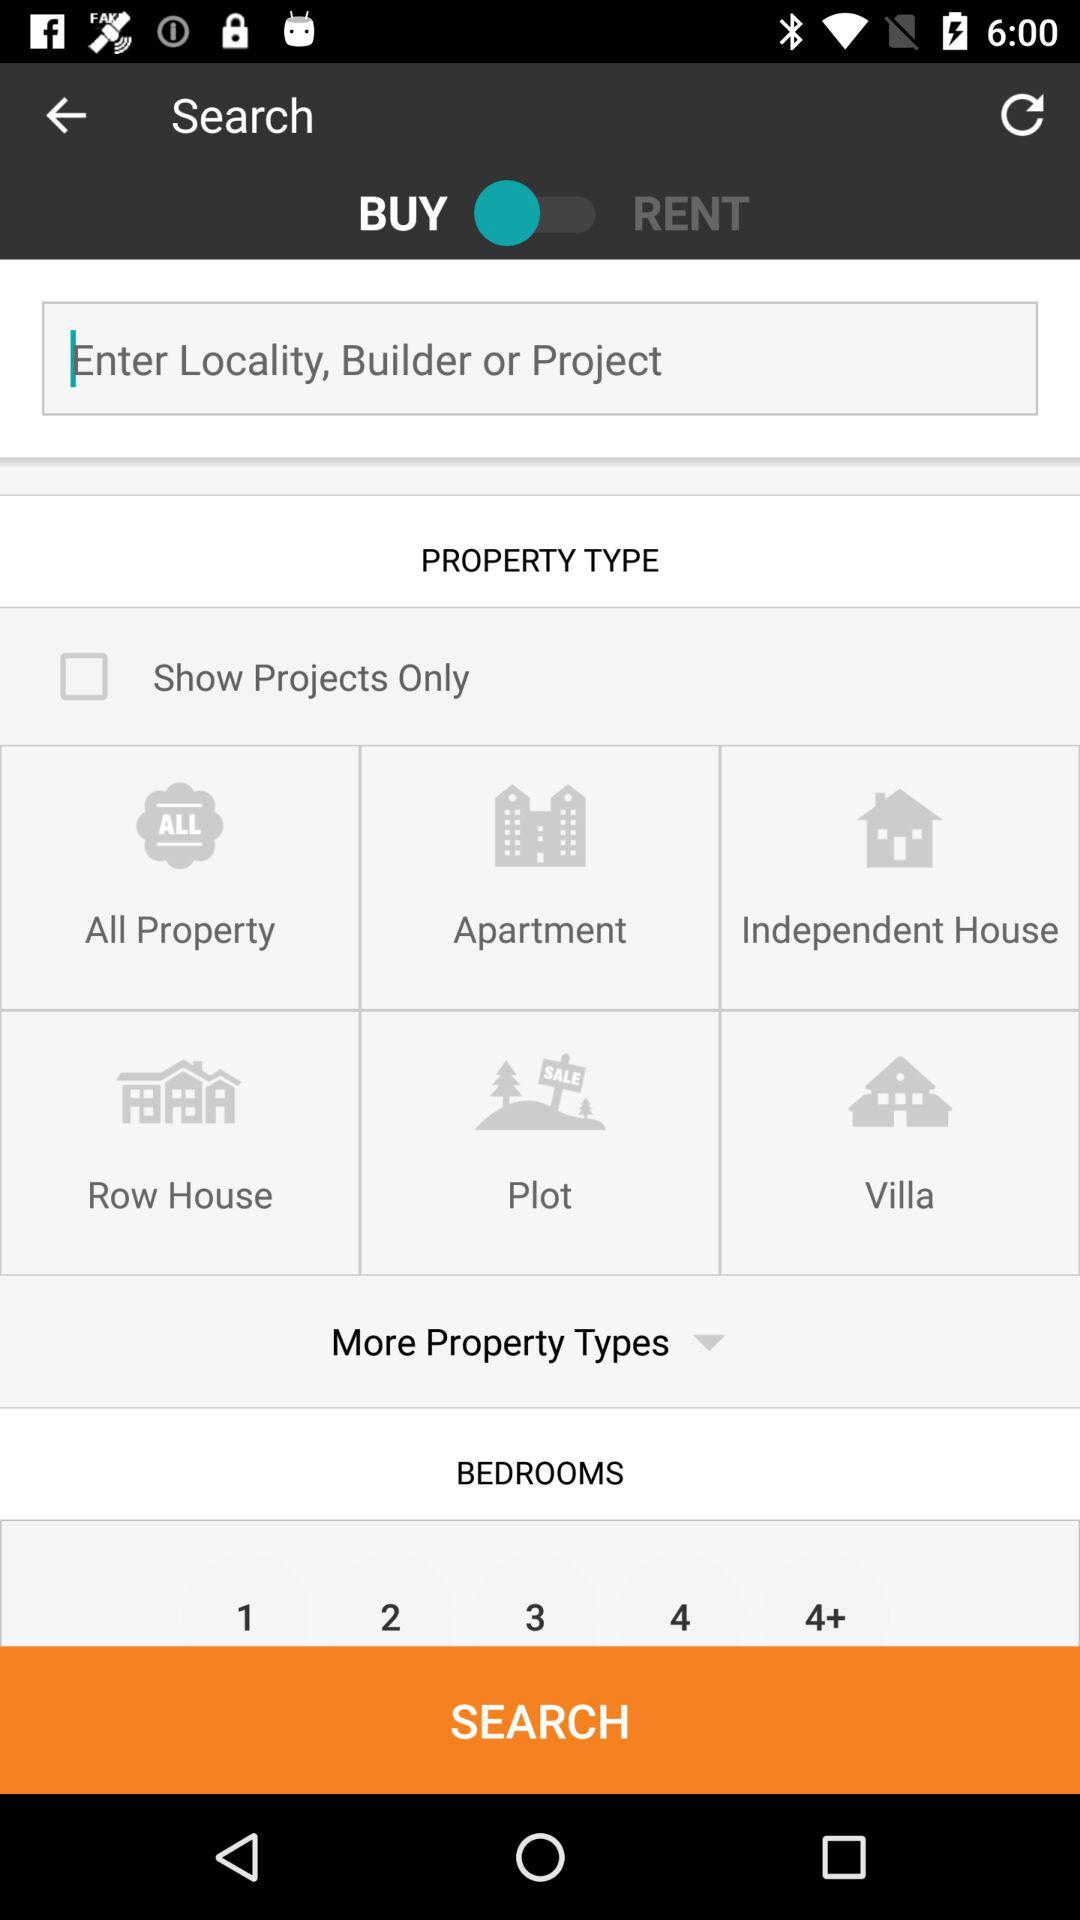How many bedrooms have been selected?
When the provided information is insufficient, respond with <no answer>. <no answer> 